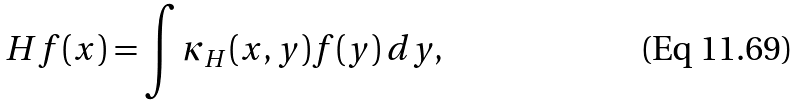Convert formula to latex. <formula><loc_0><loc_0><loc_500><loc_500>H f ( x ) = \int \kappa _ { H } ( x , y ) f ( y ) \, d y ,</formula> 